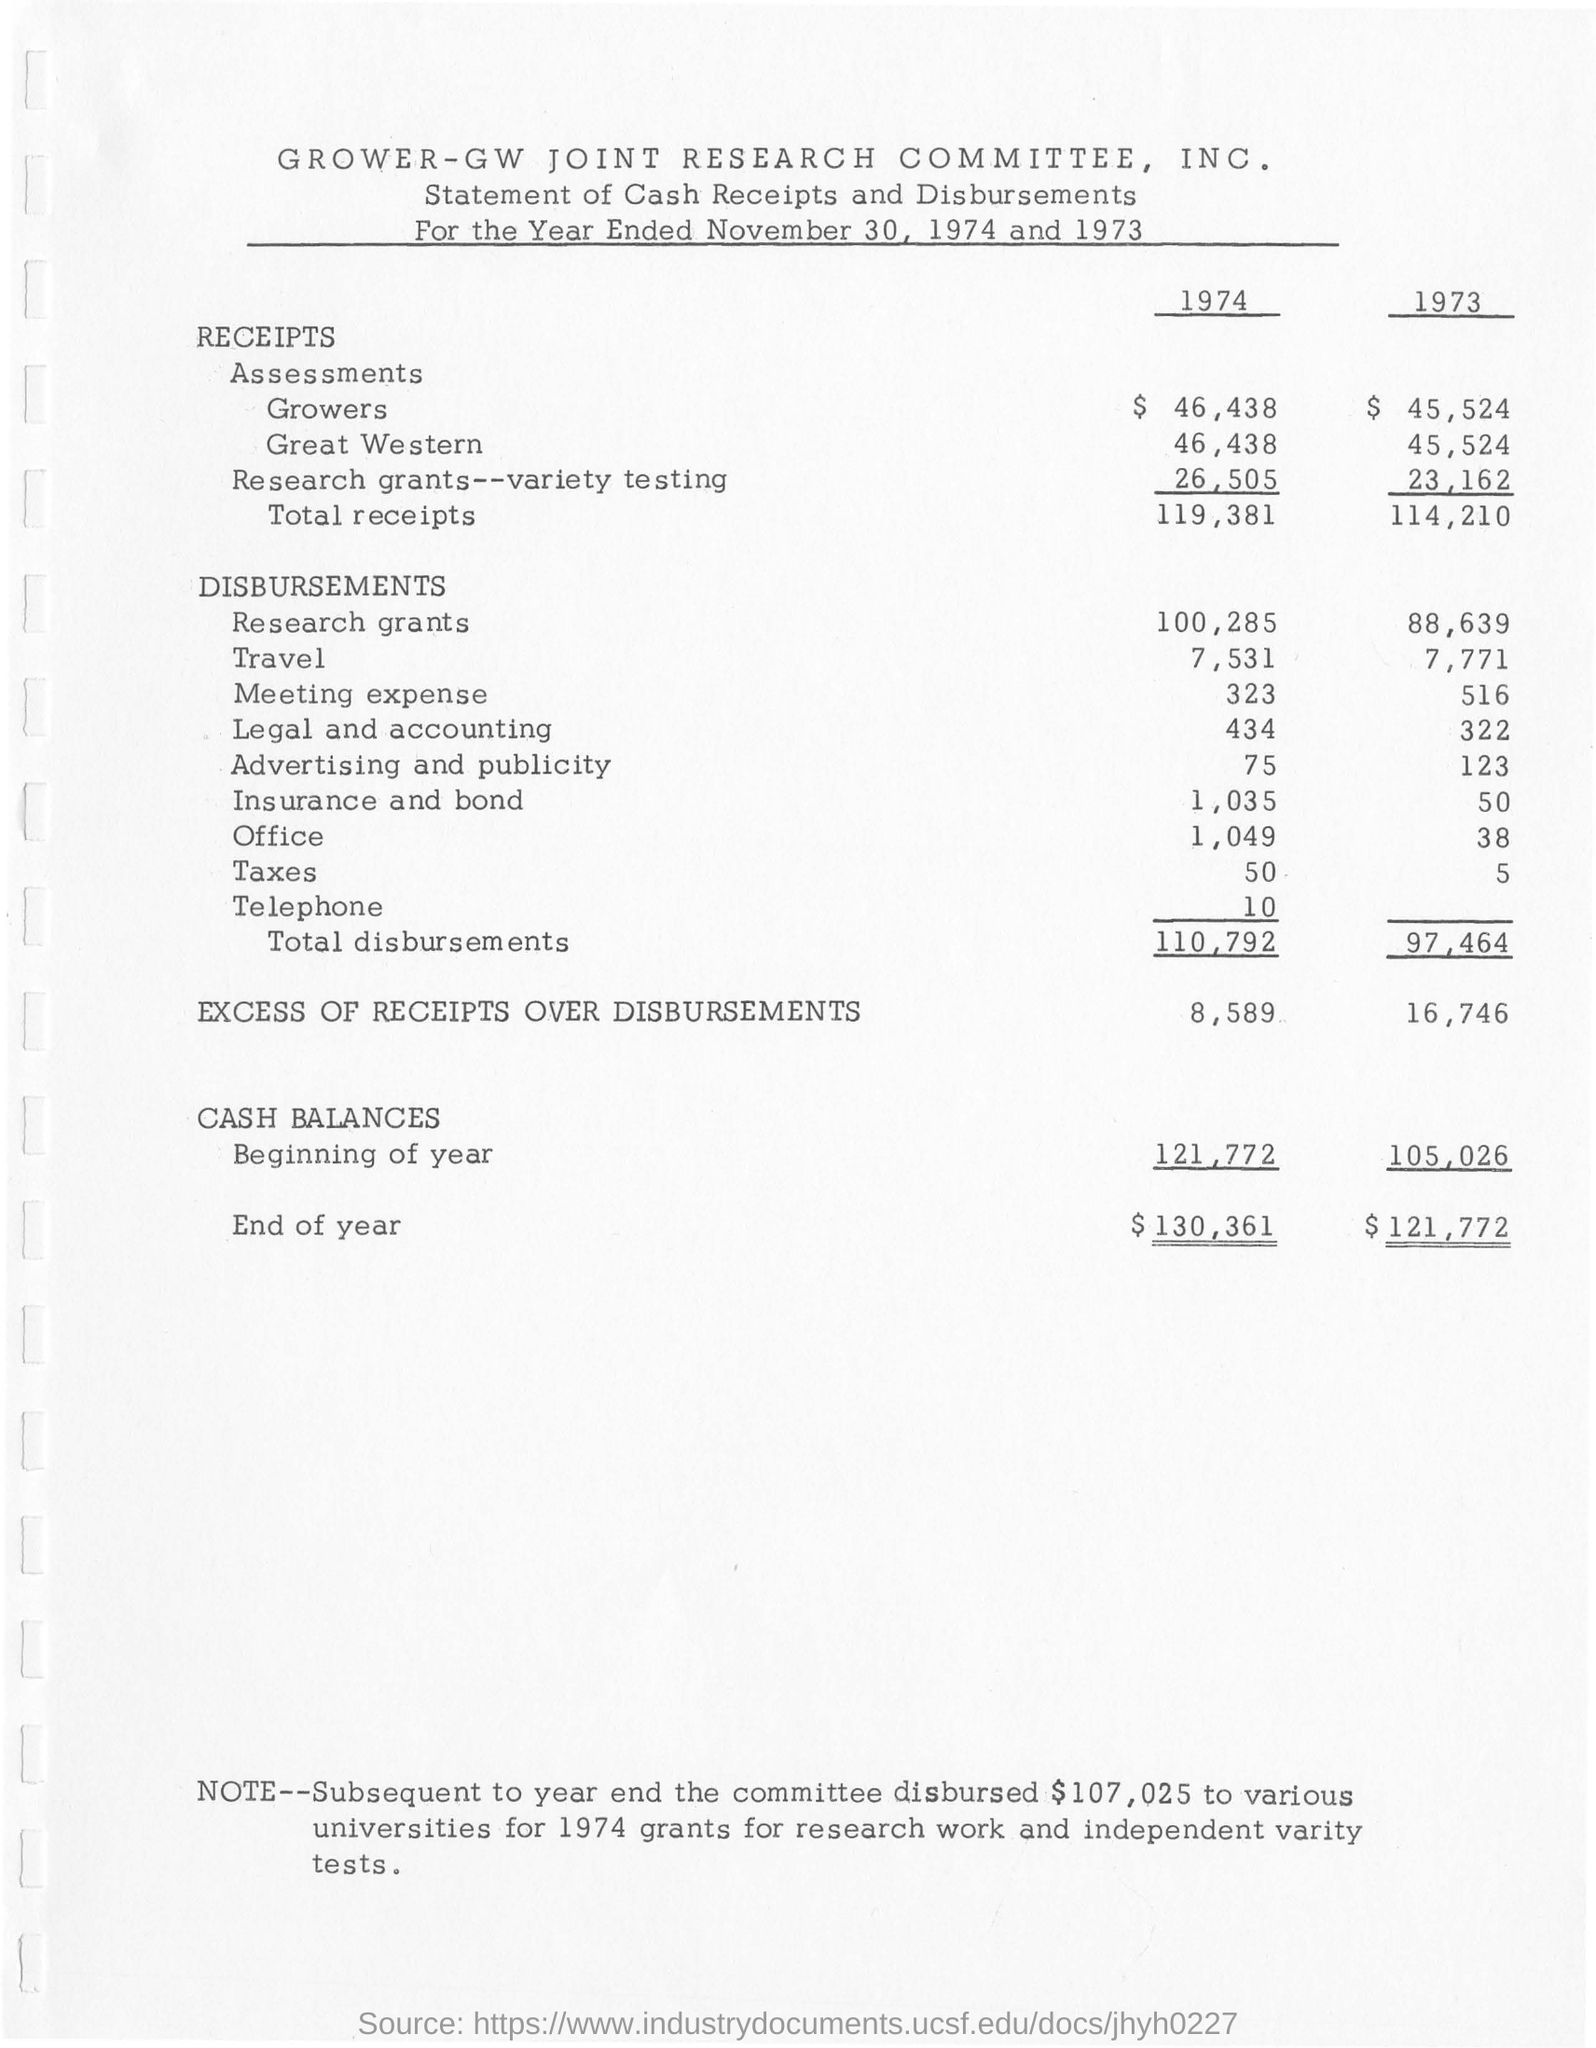What is this document about?
Offer a very short reply. STATEMENT OF CASH RECEIPTS AND DISBURSEMENTS. How much is the Cash Balances in the beginning of the year 1974?
Ensure brevity in your answer.  121,772. How much is the Cash Balances in the end of the year 1974?
Provide a short and direct response. $130,361. What is the amount of total disbursements in the year 1973?
Make the answer very short. 97,464. How much is the excess of receipts over disbursements in the year 1974 amounts to?
Ensure brevity in your answer.  8,589. 